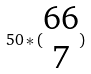<formula> <loc_0><loc_0><loc_500><loc_500>5 0 * ( \begin{matrix} 6 6 \\ 7 \end{matrix} )</formula> 